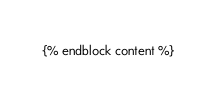<code> <loc_0><loc_0><loc_500><loc_500><_HTML_>

{% endblock content %}
</code> 